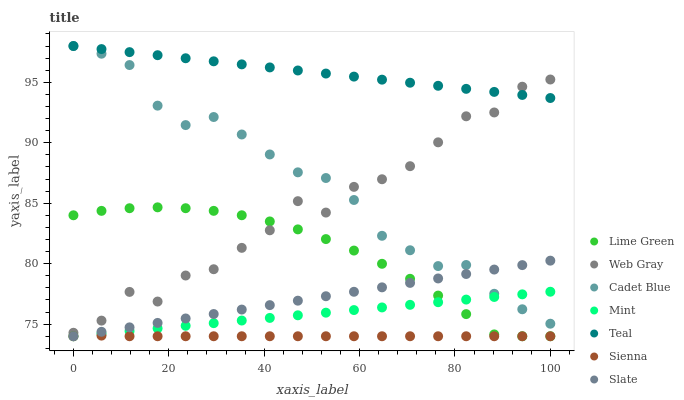Does Sienna have the minimum area under the curve?
Answer yes or no. Yes. Does Teal have the maximum area under the curve?
Answer yes or no. Yes. Does Lime Green have the minimum area under the curve?
Answer yes or no. No. Does Lime Green have the maximum area under the curve?
Answer yes or no. No. Is Slate the smoothest?
Answer yes or no. Yes. Is Web Gray the roughest?
Answer yes or no. Yes. Is Lime Green the smoothest?
Answer yes or no. No. Is Lime Green the roughest?
Answer yes or no. No. Does Lime Green have the lowest value?
Answer yes or no. Yes. Does Web Gray have the lowest value?
Answer yes or no. No. Does Teal have the highest value?
Answer yes or no. Yes. Does Lime Green have the highest value?
Answer yes or no. No. Is Sienna less than Web Gray?
Answer yes or no. Yes. Is Web Gray greater than Sienna?
Answer yes or no. Yes. Does Cadet Blue intersect Slate?
Answer yes or no. Yes. Is Cadet Blue less than Slate?
Answer yes or no. No. Is Cadet Blue greater than Slate?
Answer yes or no. No. Does Sienna intersect Web Gray?
Answer yes or no. No. 